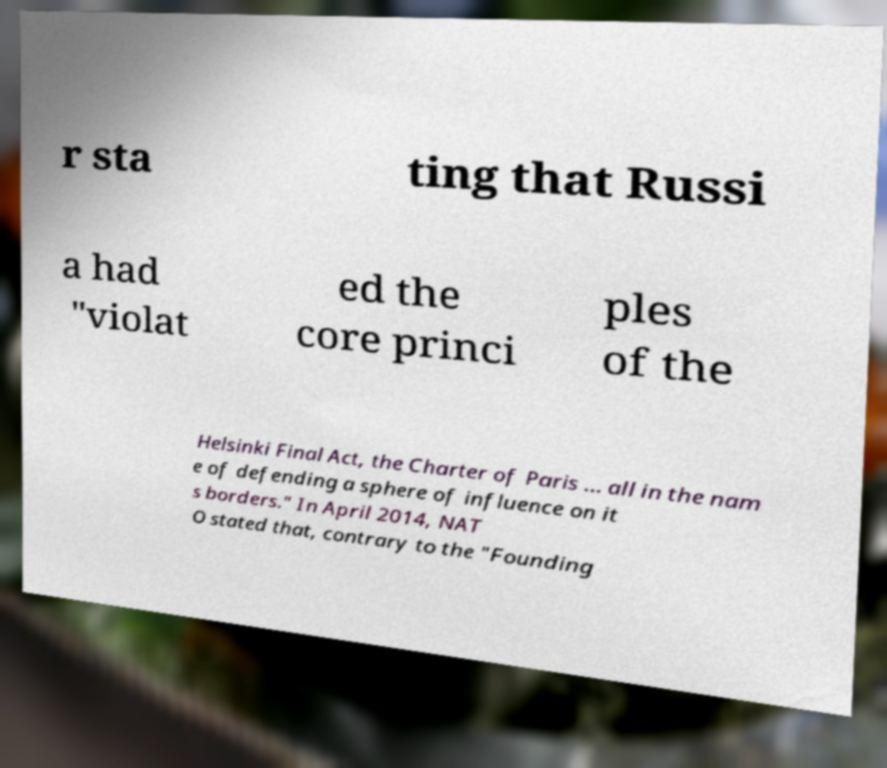Can you accurately transcribe the text from the provided image for me? r sta ting that Russi a had "violat ed the core princi ples of the Helsinki Final Act, the Charter of Paris ... all in the nam e of defending a sphere of influence on it s borders." In April 2014, NAT O stated that, contrary to the "Founding 